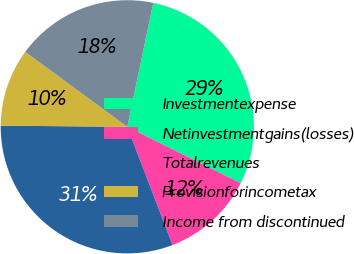<chart> <loc_0><loc_0><loc_500><loc_500><pie_chart><fcel>Investmentexpense<fcel>Netinvestmentgains(losses)<fcel>Totalrevenues<fcel>Provisionforincometax<fcel>Income from discontinued<nl><fcel>29.05%<fcel>11.85%<fcel>30.96%<fcel>9.94%<fcel>18.21%<nl></chart> 